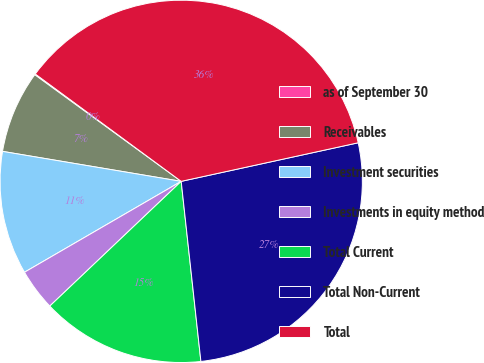Convert chart to OTSL. <chart><loc_0><loc_0><loc_500><loc_500><pie_chart><fcel>as of September 30<fcel>Receivables<fcel>Investment securities<fcel>Investments in equity method<fcel>Total Current<fcel>Total Non-Current<fcel>Total<nl><fcel>0.08%<fcel>7.37%<fcel>11.01%<fcel>3.72%<fcel>14.65%<fcel>26.68%<fcel>36.49%<nl></chart> 